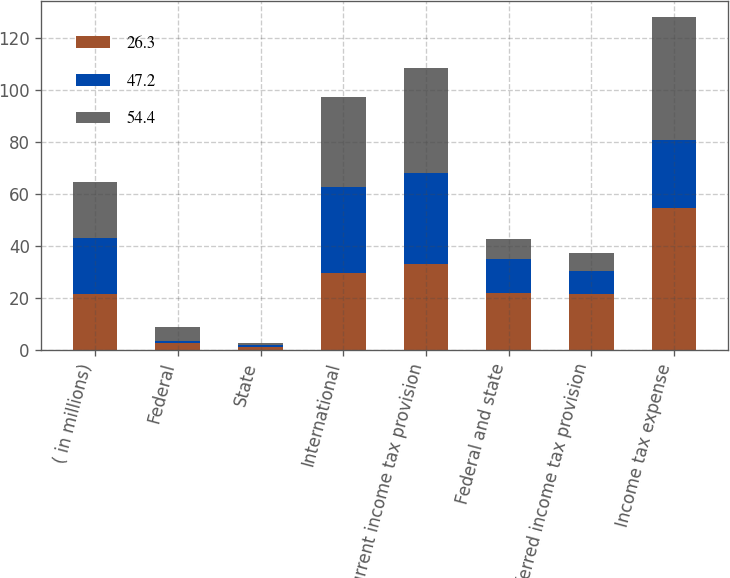Convert chart to OTSL. <chart><loc_0><loc_0><loc_500><loc_500><stacked_bar_chart><ecel><fcel>( in millions)<fcel>Federal<fcel>State<fcel>International<fcel>Current income tax provision<fcel>Federal and state<fcel>Deferred income tax provision<fcel>Income tax expense<nl><fcel>26.3<fcel>21.5<fcel>2.5<fcel>1<fcel>29.4<fcel>32.9<fcel>21.8<fcel>21.5<fcel>54.4<nl><fcel>47.2<fcel>21.5<fcel>1<fcel>0.9<fcel>33.3<fcel>35.2<fcel>13.2<fcel>8.9<fcel>26.3<nl><fcel>54.4<fcel>21.5<fcel>5.2<fcel>0.5<fcel>34.5<fcel>40.2<fcel>7.7<fcel>7<fcel>47.2<nl></chart> 